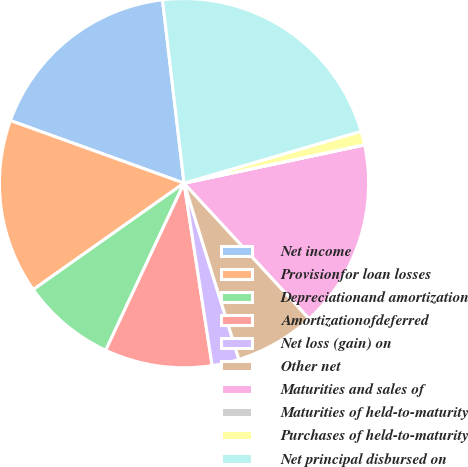<chart> <loc_0><loc_0><loc_500><loc_500><pie_chart><fcel>Net income<fcel>Provisionfor loan losses<fcel>Depreciationand amortization<fcel>Amortizationofdeferred<fcel>Net loss (gain) on<fcel>Other net<fcel>Maturities and sales of<fcel>Maturities of held-to-maturity<fcel>Purchases of held-to-maturity<fcel>Net principal disbursed on<nl><fcel>17.63%<fcel>15.29%<fcel>8.24%<fcel>9.41%<fcel>2.37%<fcel>7.06%<fcel>16.46%<fcel>0.02%<fcel>1.19%<fcel>22.33%<nl></chart> 